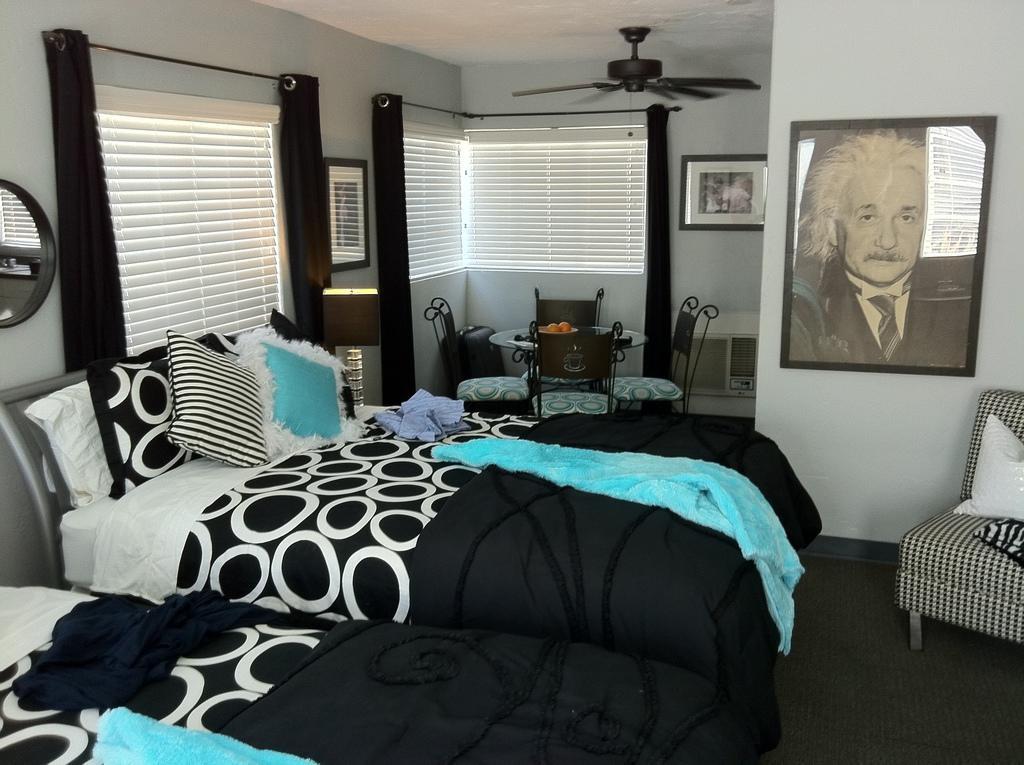In one or two sentences, can you explain what this image depicts? We can see pillows and clothes on beds and we can see bed on chair. We can see chairs and objects on the table and we can see frames and mirror on the wall. We can see curtains and windows. Top we can see fan. 